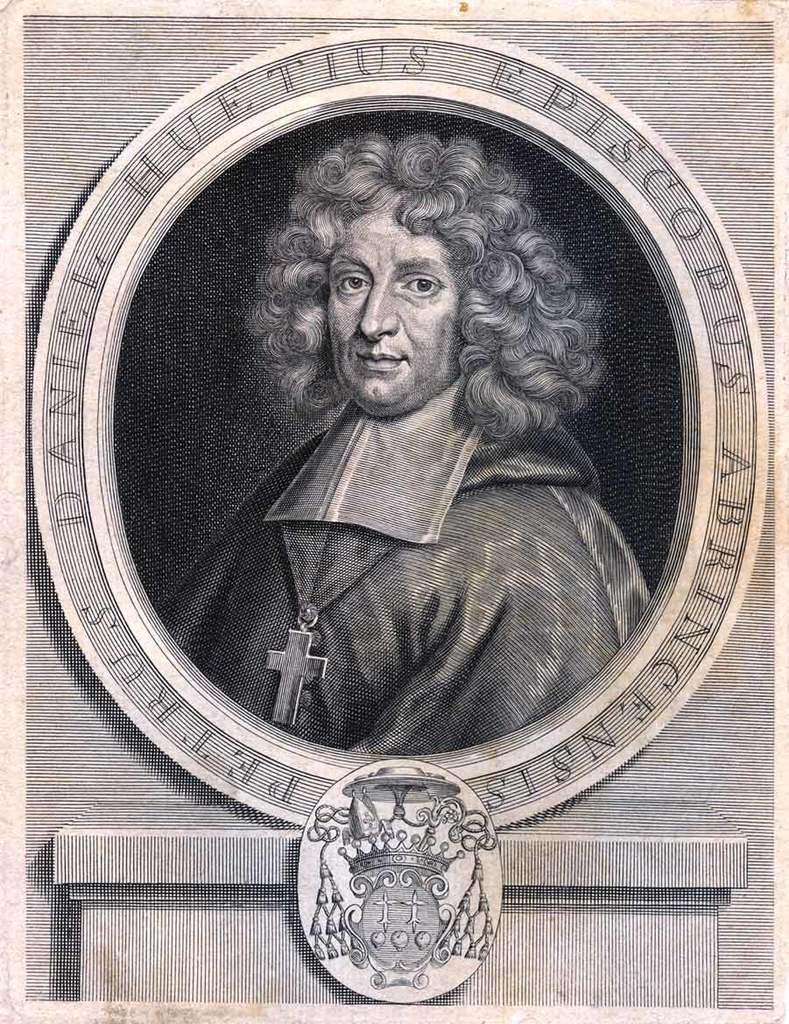What type of visual is the image? The image is a poster. What is depicted on the poster? There is a picture of a person on the poster. What else can be seen on the poster besides the person? There is some art and text on the poster. What type of wall is depicted in the poster? There is no wall depicted in the poster; it is a poster with a picture of a person, art, and text. 